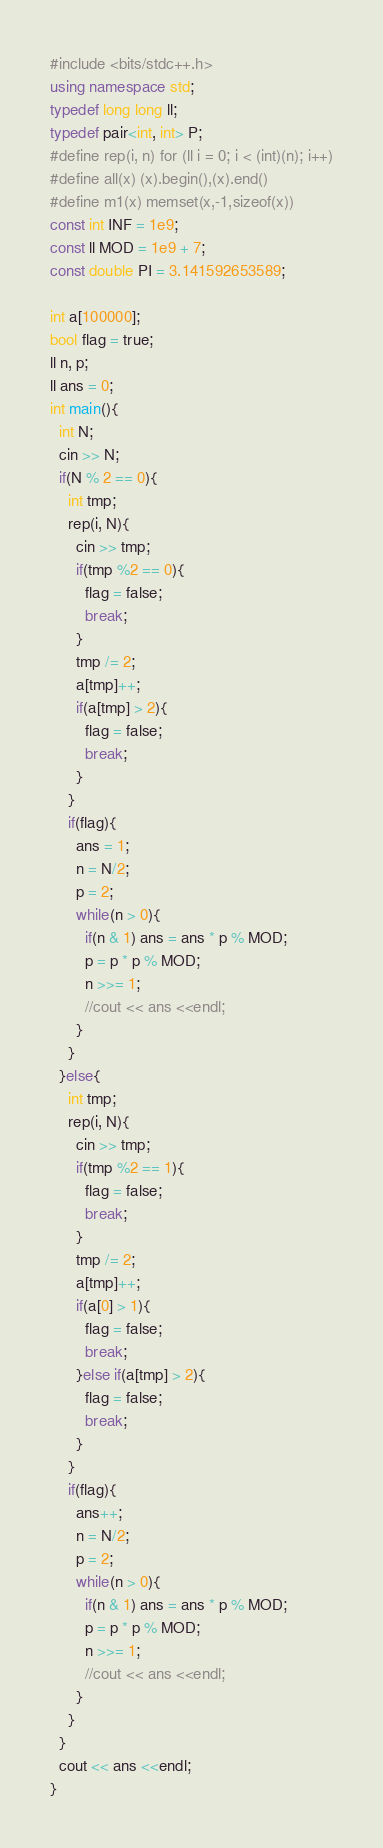Convert code to text. <code><loc_0><loc_0><loc_500><loc_500><_C++_>#include <bits/stdc++.h>
using namespace std;
typedef long long ll;
typedef pair<int, int> P;
#define rep(i, n) for (ll i = 0; i < (int)(n); i++)
#define all(x) (x).begin(),(x).end()
#define m1(x) memset(x,-1,sizeof(x))
const int INF = 1e9;
const ll MOD = 1e9 + 7;
const double PI = 3.141592653589;

int a[100000];
bool flag = true;
ll n, p;
ll ans = 0;
int main(){
  int N;
  cin >> N;
  if(N % 2 == 0){
    int tmp;
    rep(i, N){
      cin >> tmp;
      if(tmp %2 == 0){
        flag = false;
        break;
      }
      tmp /= 2;
      a[tmp]++;
      if(a[tmp] > 2){
        flag = false;
        break;
      }
    }
    if(flag){
      ans = 1;
      n = N/2;
      p = 2;
      while(n > 0){
        if(n & 1) ans = ans * p % MOD;
        p = p * p % MOD;
        n >>= 1;
        //cout << ans <<endl;
      }
    } 
  }else{
    int tmp;
    rep(i, N){
      cin >> tmp;
      if(tmp %2 == 1){
        flag = false;
        break;
      }
      tmp /= 2;
      a[tmp]++;
      if(a[0] > 1){
        flag = false;
        break;
      }else if(a[tmp] > 2){
        flag = false;
        break;
      }
    }
    if(flag){
      ans++;
      n = N/2;
      p = 2;
      while(n > 0){
        if(n & 1) ans = ans * p % MOD;
        p = p * p % MOD;
        n >>= 1;
        //cout << ans <<endl;
      }
    }
  }
  cout << ans <<endl;
}</code> 